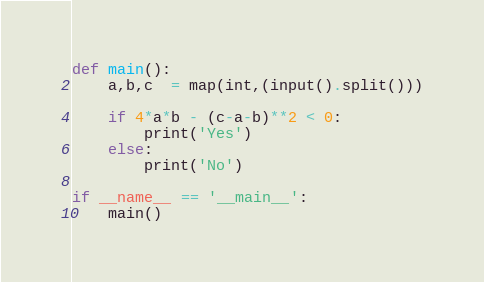Convert code to text. <code><loc_0><loc_0><loc_500><loc_500><_Python_>def main():
    a,b,c  = map(int,(input().split()))

    if 4*a*b - (c-a-b)**2 < 0:
        print('Yes')
    else:
        print('No')

if __name__ == '__main__':
    main()
</code> 